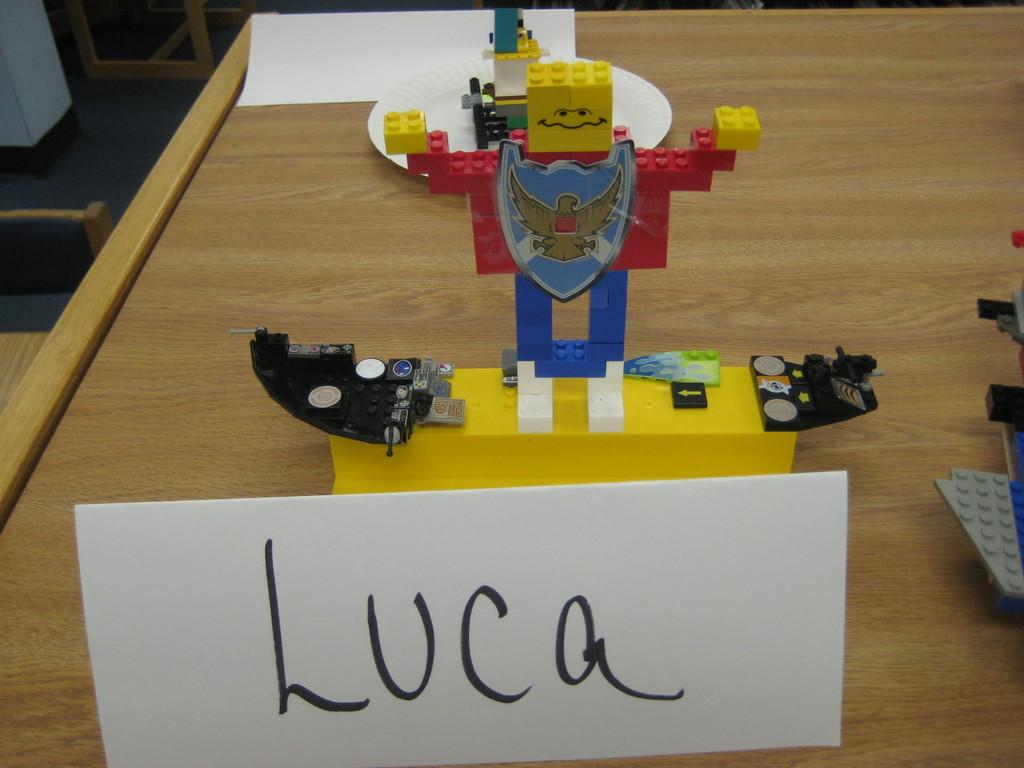What type of object is in the image? There is a toy in the image. What material is the toy made of? The toy is made with legos. Where is the toy located in the image? The toy is placed on a table. What actor is holding the toy in the image? There is no actor present in the image; it only shows a toy made with legos placed on a table. 